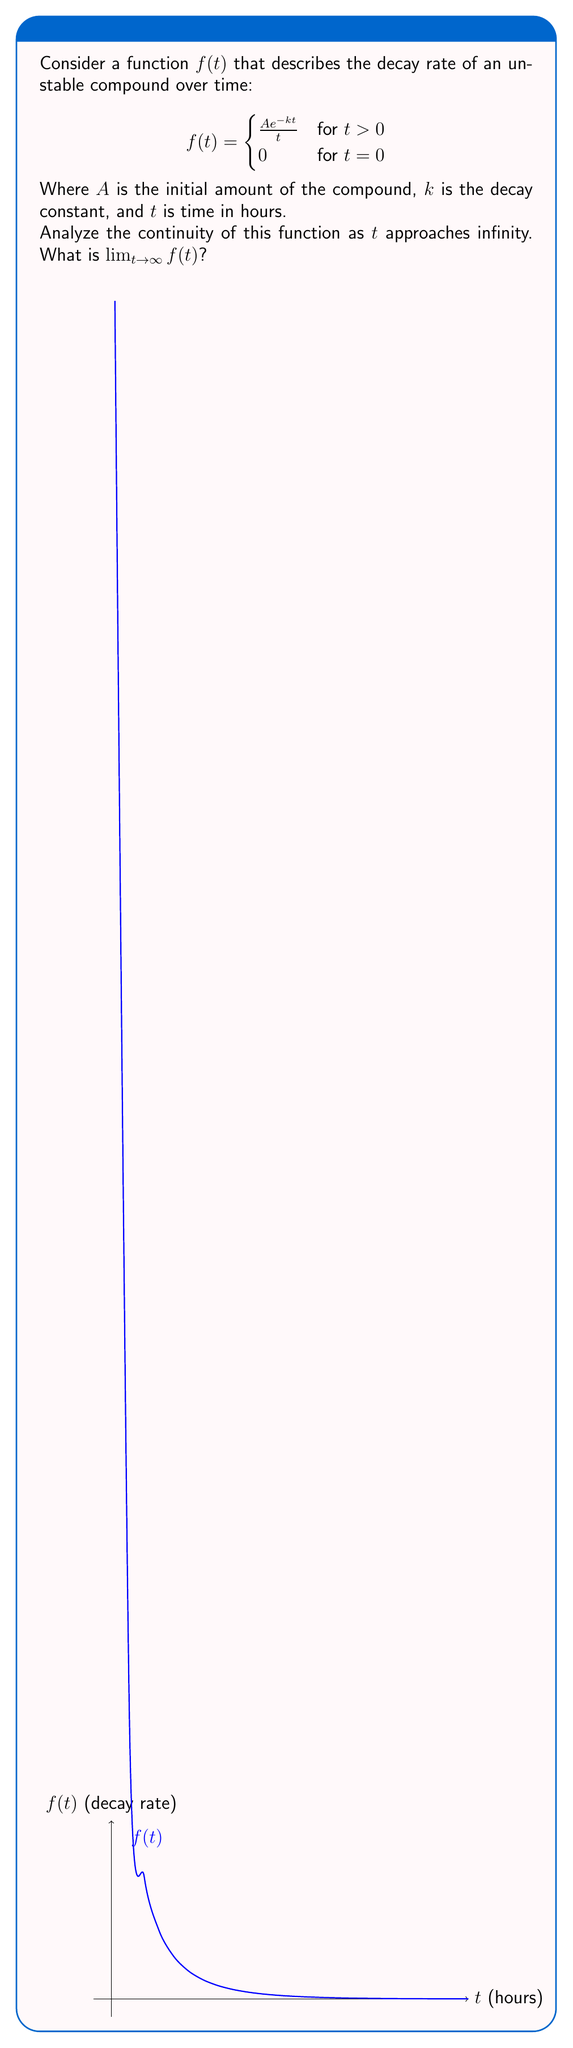Give your solution to this math problem. To analyze the continuity of $f(t)$ as $t$ approaches infinity and find $\lim_{t \to \infty} f(t)$, we'll follow these steps:

1) First, let's consider the limit:
   $$\lim_{t \to \infty} f(t) = \lim_{t \to \infty} \frac{A e^{-kt}}{t}$$

2) We can rewrite this as:
   $$\lim_{t \to \infty} \frac{A e^{-kt}}{t} = A \lim_{t \to \infty} \frac{e^{-kt}}{t}$$

3) Now, we can apply L'Hôpital's rule, as both numerator and denominator approach 0 as $t \to \infty$:
   $$A \lim_{t \to \infty} \frac{e^{-kt}}{t} = A \lim_{t \to \infty} \frac{-k e^{-kt}}{1} = -Ak \lim_{t \to \infty} e^{-kt}$$

4) As $t \to \infty$, $e^{-kt} \to 0$ for any positive $k$:
   $$-Ak \lim_{t \to \infty} e^{-kt} = 0$$

5) Therefore, $\lim_{t \to \infty} f(t) = 0$.

6) To check continuity at infinity, we need to verify if the limit exists and if it equals the function value at infinity (if defined). Since the limit exists and equals 0, and the function approaches 0 as $t$ increases, we can conclude that $f(t)$ is continuous as $t$ approaches infinity.
Answer: $\lim_{t \to \infty} f(t) = 0$; $f(t)$ is continuous as $t$ approaches infinity. 